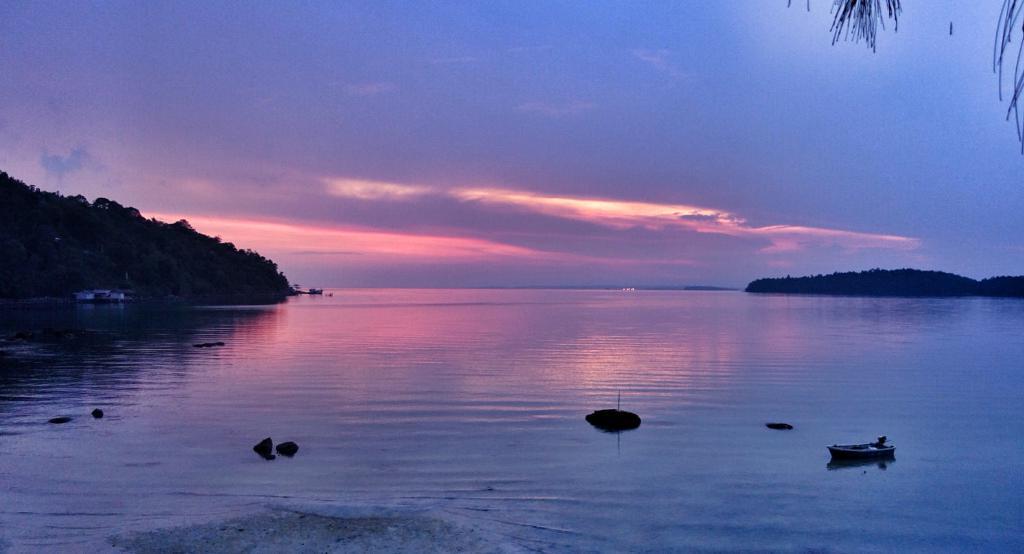Could you give a brief overview of what you see in this image? In the picture I can see boats on the water and trees. In the background I can see the sky. 